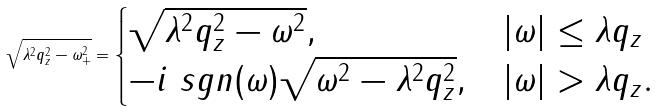Convert formula to latex. <formula><loc_0><loc_0><loc_500><loc_500>\sqrt { \lambda ^ { 2 } q _ { z } ^ { 2 } - \omega _ { + } ^ { 2 } } = \begin{cases} \sqrt { \lambda ^ { 2 } q _ { z } ^ { 2 } - \omega ^ { 2 } } , & | \omega | \leq \lambda q _ { z } \\ - i \ s g n ( \omega ) \sqrt { \omega ^ { 2 } - \lambda ^ { 2 } q _ { z } ^ { 2 } } , & | \omega | > \lambda q _ { z } . \end{cases}</formula> 